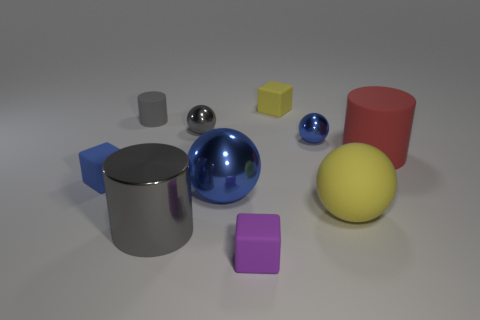Subtract all purple cylinders. How many blue balls are left? 2 Subtract all yellow balls. How many balls are left? 3 Subtract all large matte balls. How many balls are left? 3 Subtract all purple spheres. Subtract all blue blocks. How many spheres are left? 4 Subtract all blocks. How many objects are left? 7 Add 1 large balls. How many large balls exist? 3 Subtract 0 cyan blocks. How many objects are left? 10 Subtract all red matte cylinders. Subtract all red rubber cylinders. How many objects are left? 8 Add 5 tiny blue metallic spheres. How many tiny blue metallic spheres are left? 6 